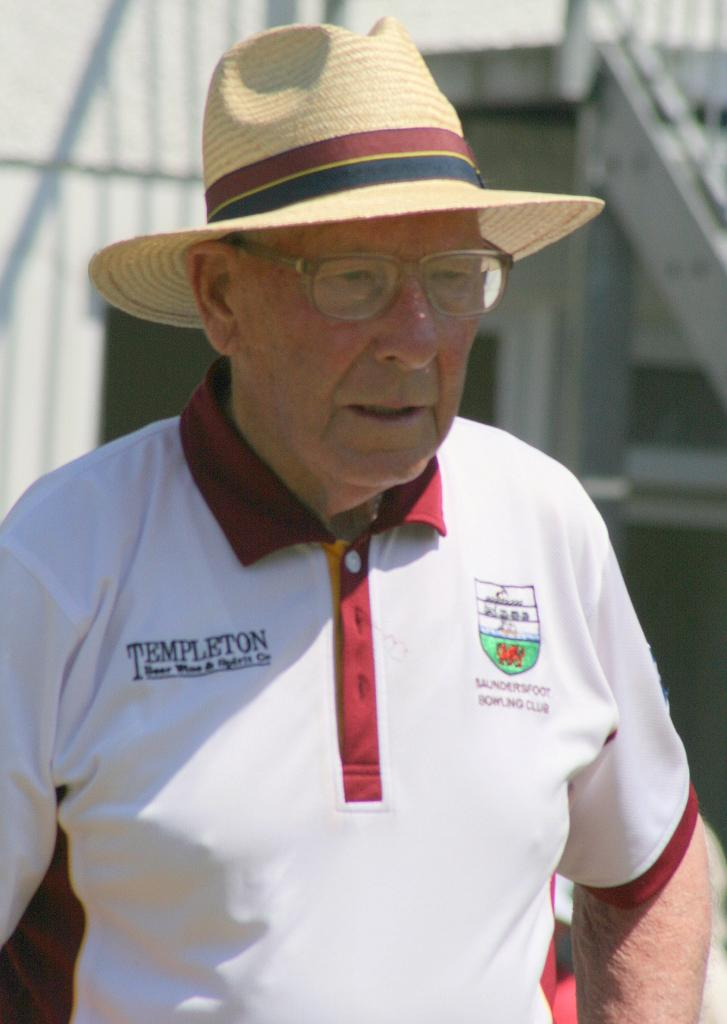<image>
Share a concise interpretation of the image provided. the old man is wearing a polo shirt with the word Templeton 